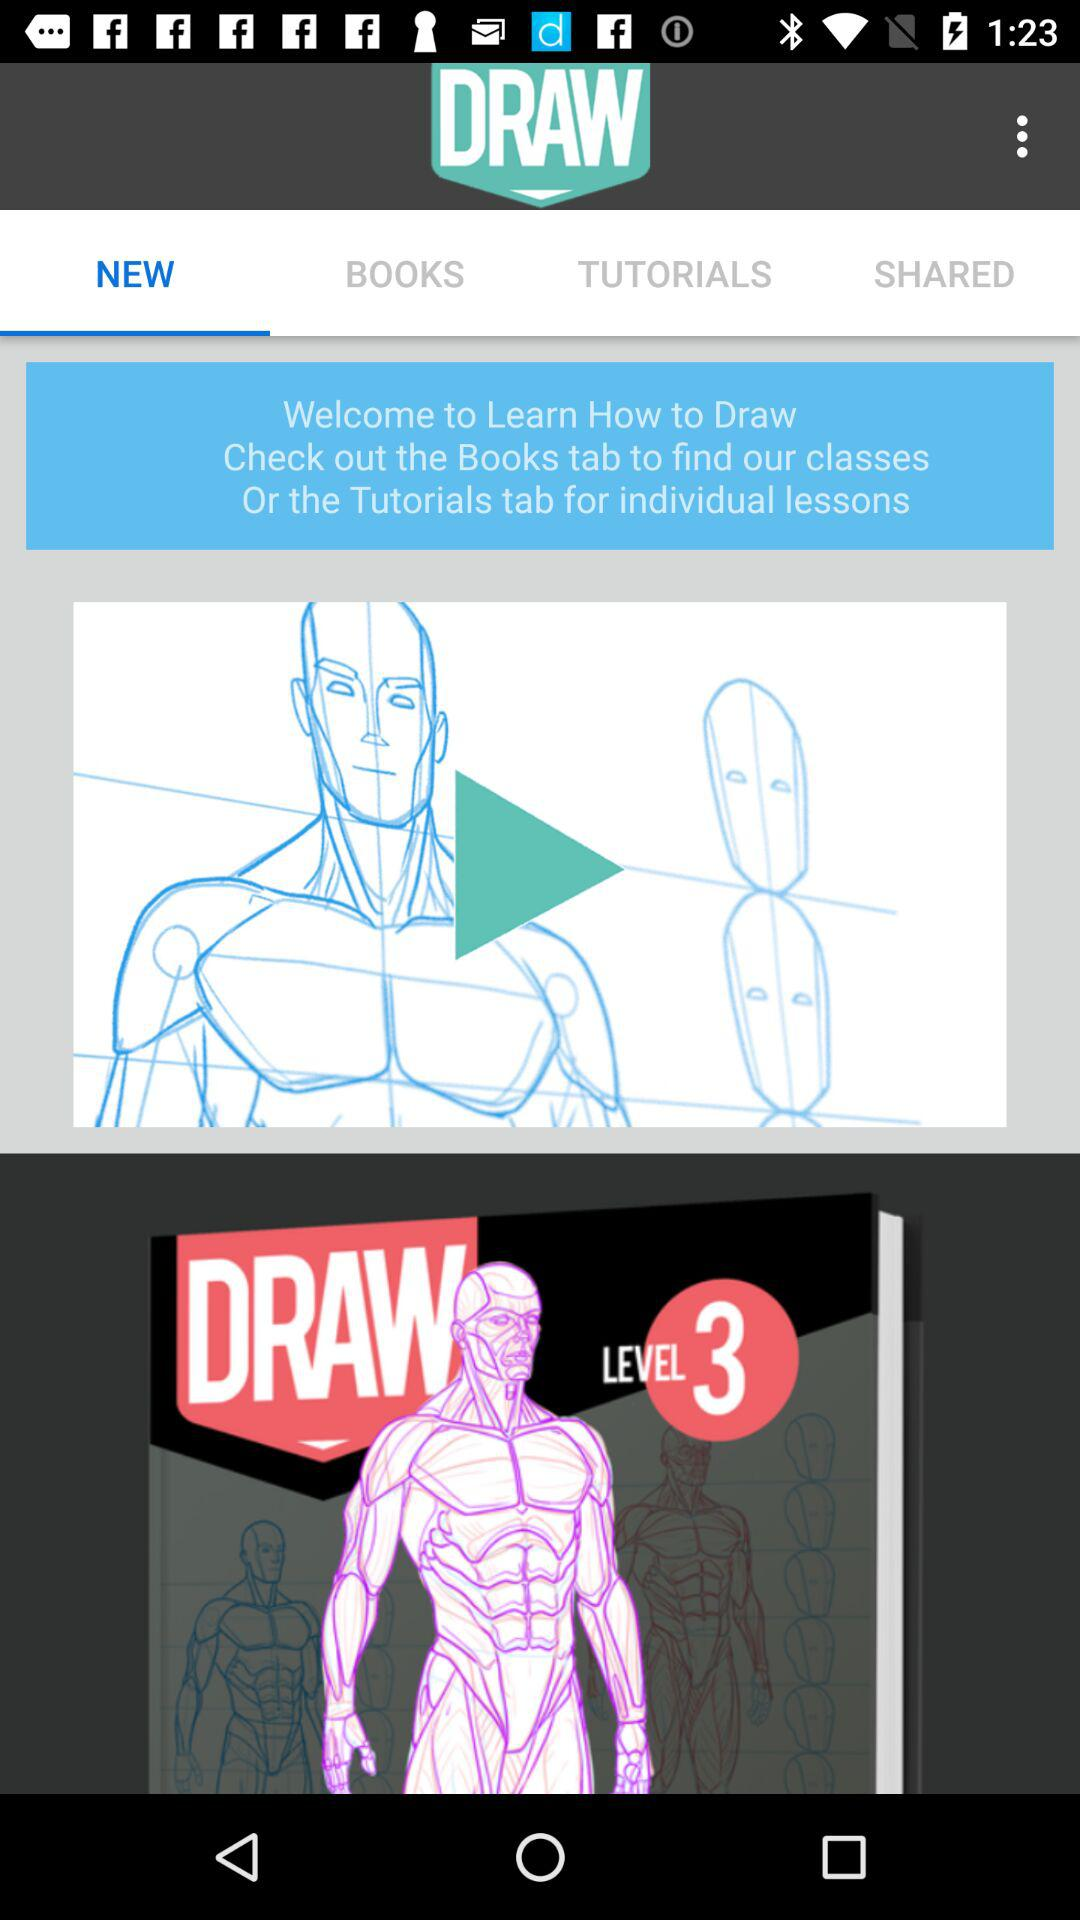What is the mentioned level? The mentioned level is 3. 